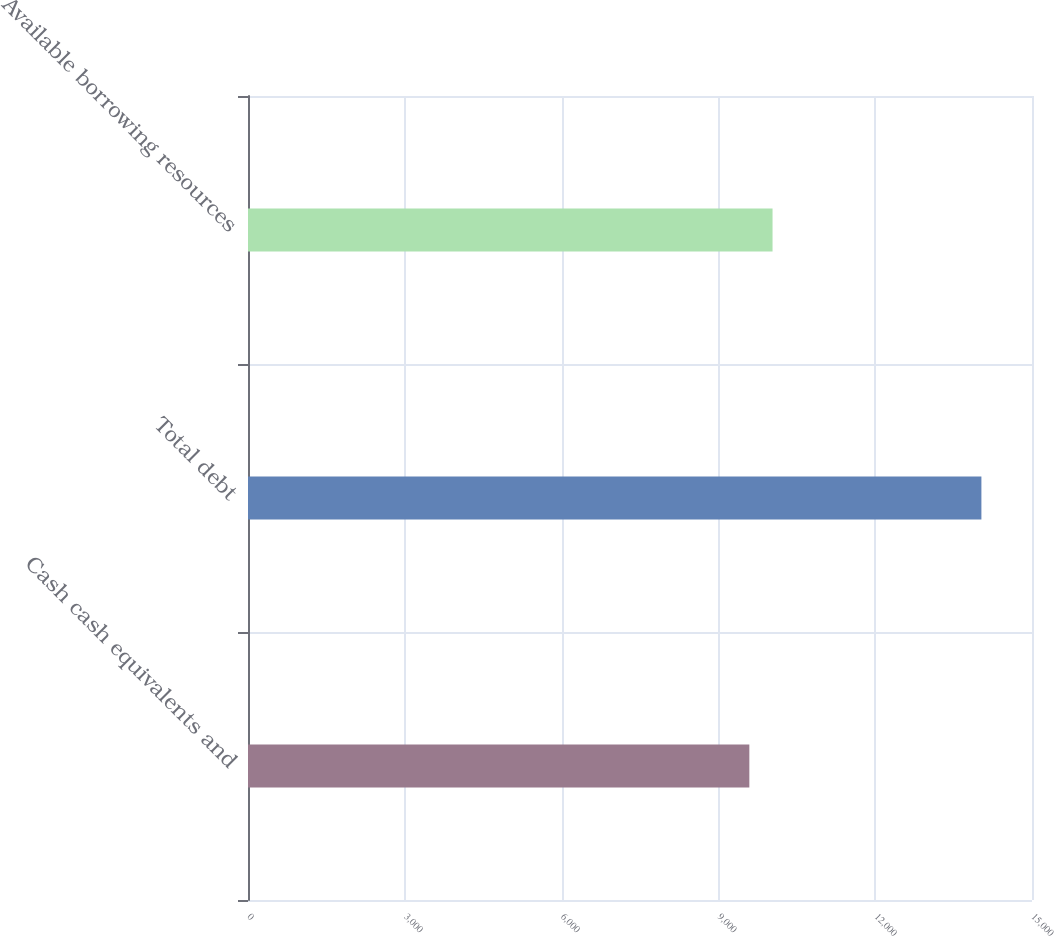<chart> <loc_0><loc_0><loc_500><loc_500><bar_chart><fcel>Cash cash equivalents and<fcel>Total debt<fcel>Available borrowing resources<nl><fcel>9592<fcel>14032<fcel>10036<nl></chart> 